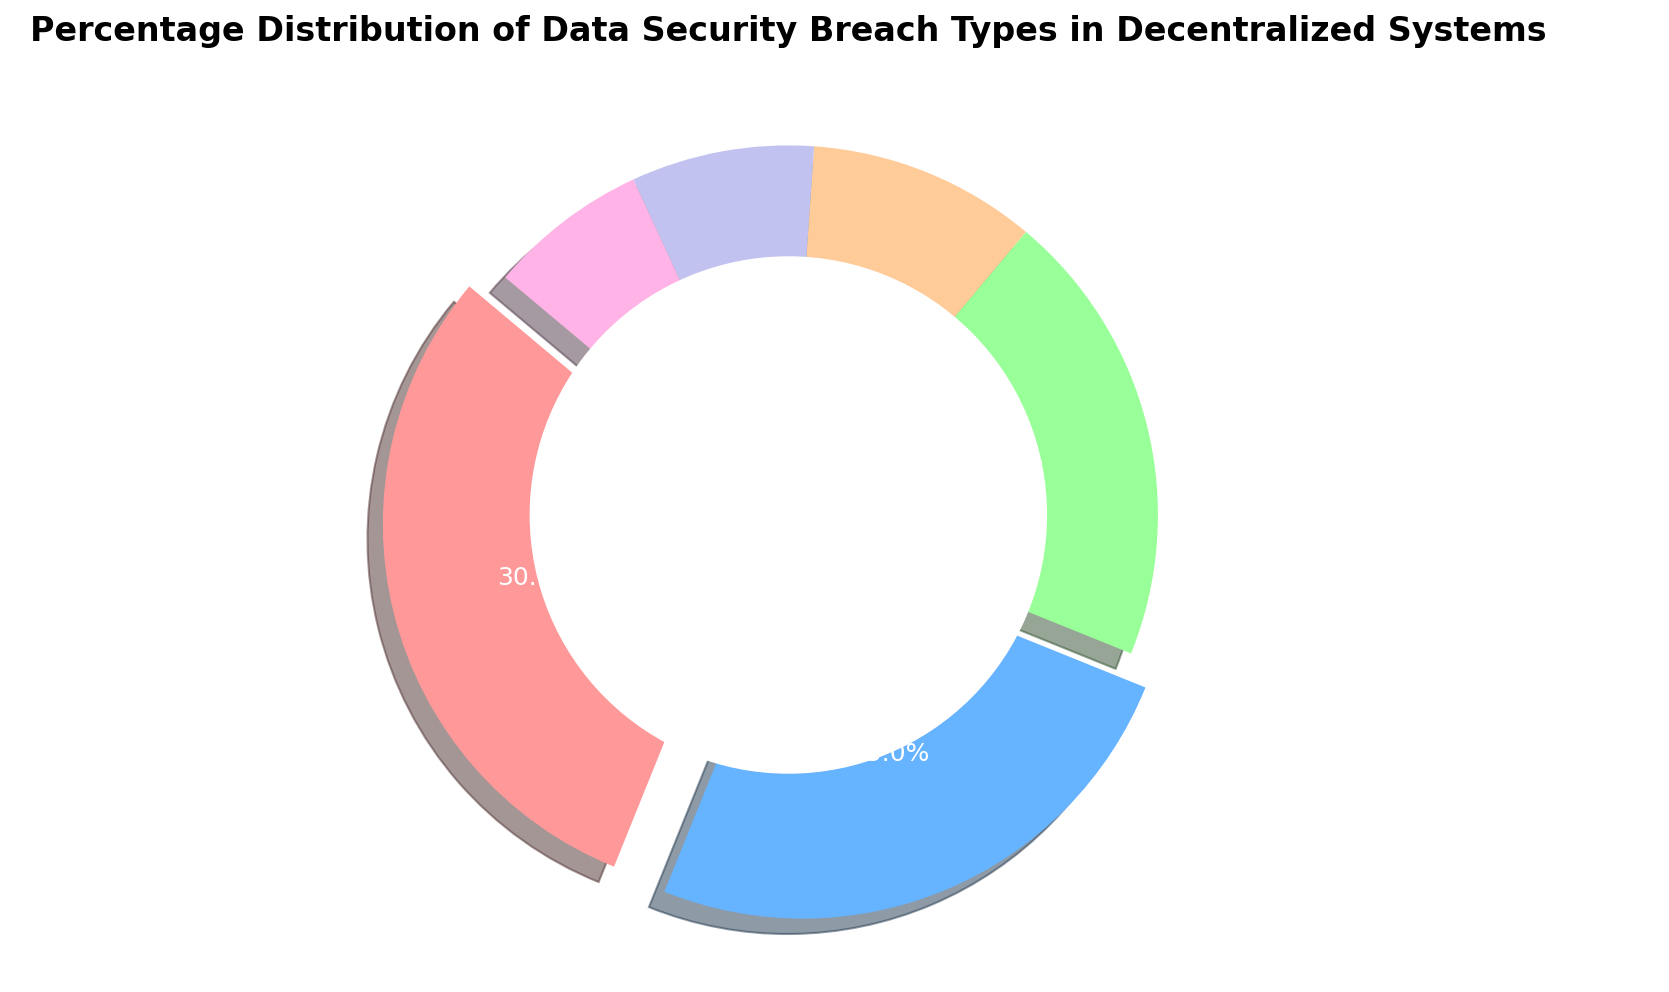Which breach type has the highest percentage? The breach type with the highest percentage can be identified by looking at the slices in the pie chart and the associated labels. Unauthorized Access has the highest percentage at 30%.
Answer: Unauthorized Access Which breach types have percentages greater than 20%? To find the breach types with percentages greater than 20%, check each label alongside its corresponding percentage. Unauthorized Access (30%) and Data Leakage (25%) both exceed 20%.
Answer: Unauthorized Access and Data Leakage Is the percentage of Smart Contract Vulnerability higher than that of Sybil Attack and DDoS Attack combined? The percentage of Smart Contract Vulnerability is 20%. The sum of Sybil Attack (10%) and DDoS Attack (8%) is 18%, which is less than the percentage of Smart Contract Vulnerability.
Answer: Yes What is the total percentage for Data Leakage and DDoS Attack combined? The percentage of Data Leakage is 25% and DDoS Attack is 8%. Adding these together, we get 25% + 8% = 33%.
Answer: 33% Which breach type has the smallest percentage? The breach type with the smallest percentage can be identified by comparing all the slices in the pie chart. The "Other" category has the smallest percentage at 7%.
Answer: Other What are the colors associated with Unauthorized Access and Data Leakage in the chart? Unauthorized Access and Data Leakage are the first two categories in the chart. Unauthorized Access is colored red and Data Leakage is colored blue.
Answer: Red and Blue 